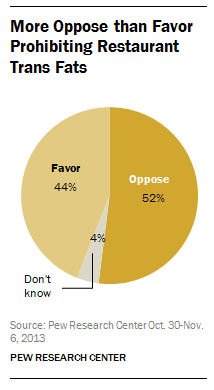Mention a couple of crucial points in this snapshot. The color of 'Don't know' is gray. The difference between the percentage of Favor and Oppose in a given situation is 8%. 